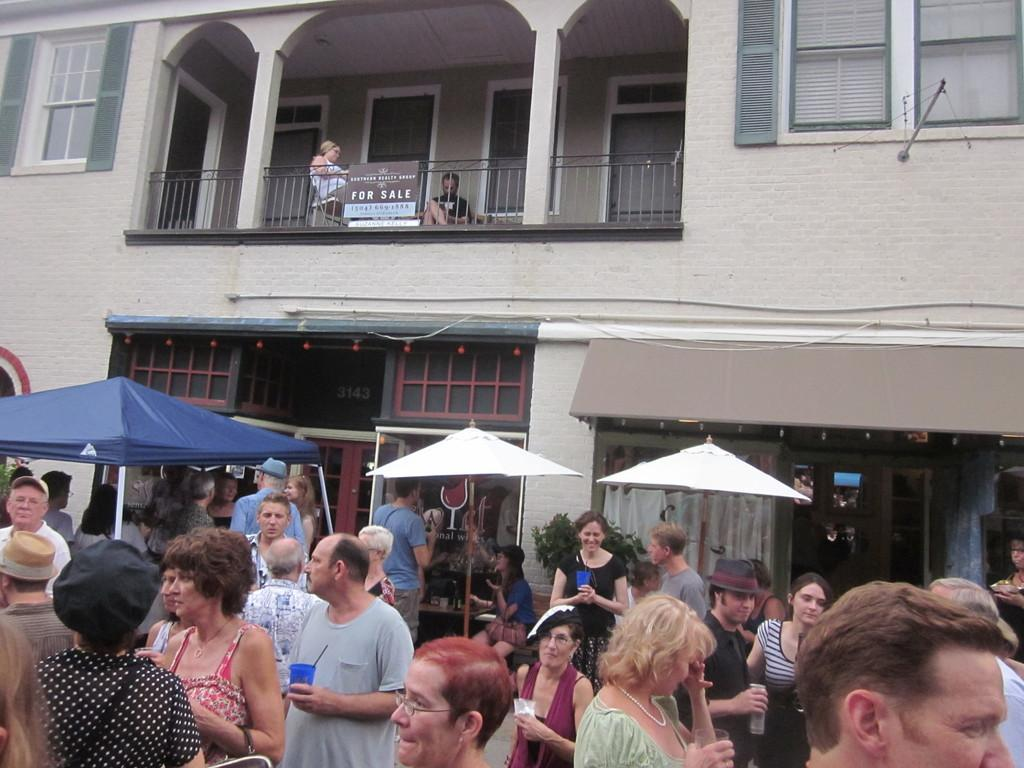<image>
Describe the image concisely. Block party located outside a home that is for sale. 